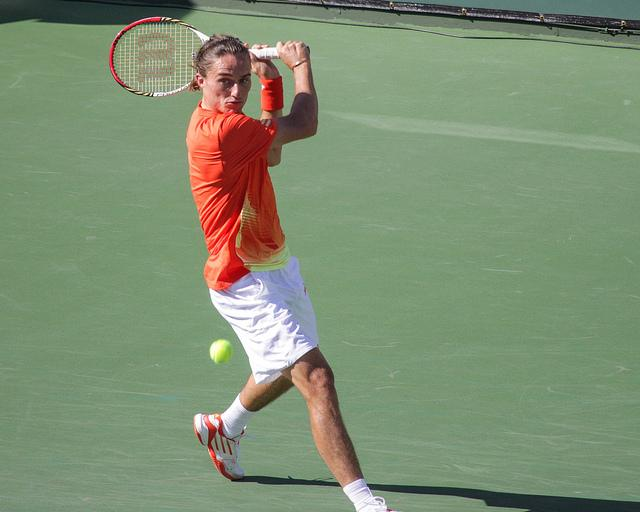Why is the man holding the racket back? swinging 